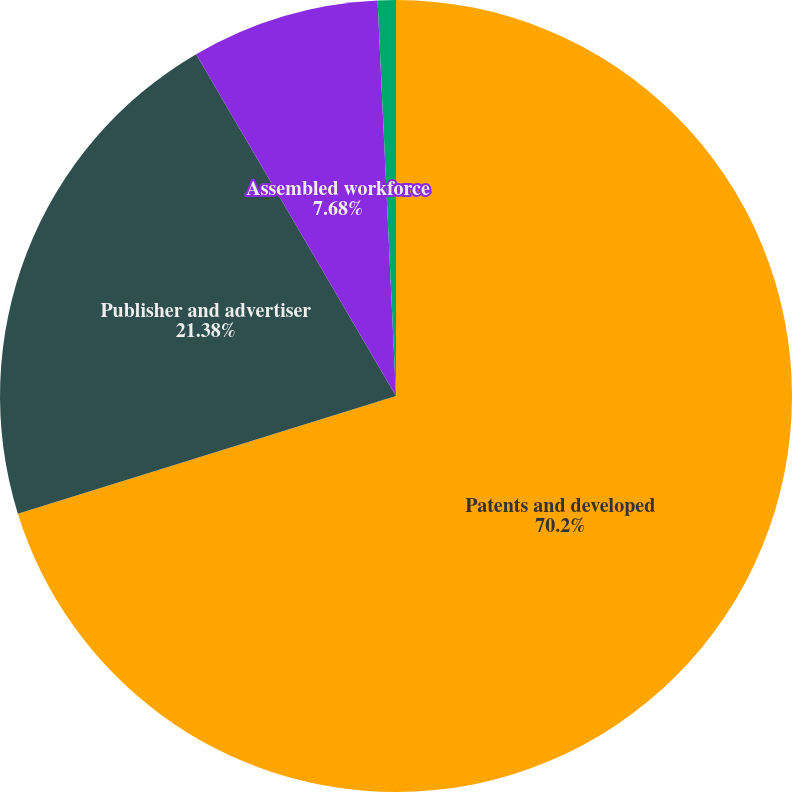<chart> <loc_0><loc_0><loc_500><loc_500><pie_chart><fcel>Patents and developed<fcel>Publisher and advertiser<fcel>Assembled workforce<fcel>Other intangible assets Total<nl><fcel>70.2%<fcel>21.38%<fcel>7.68%<fcel>0.74%<nl></chart> 